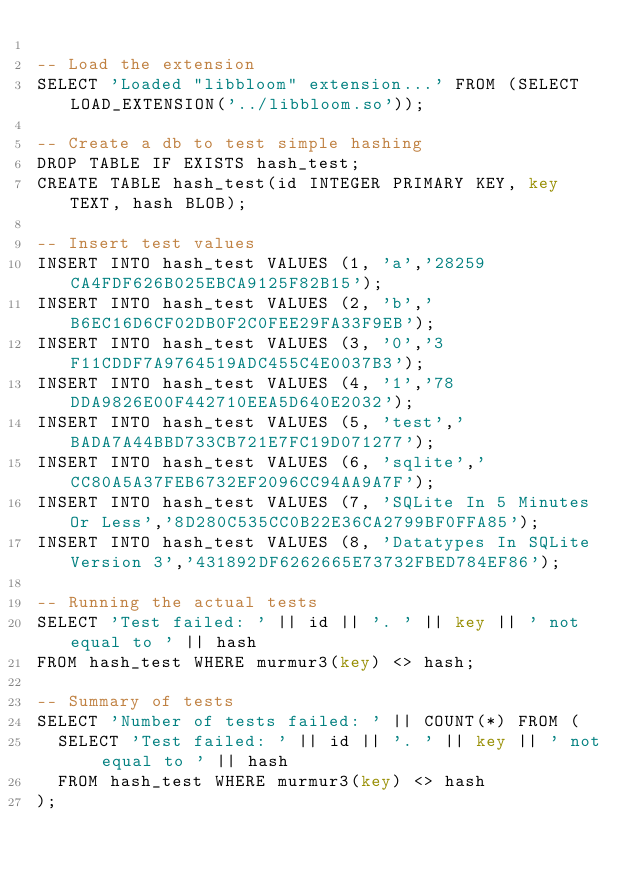<code> <loc_0><loc_0><loc_500><loc_500><_SQL_>
-- Load the extension
SELECT 'Loaded "libbloom" extension...' FROM (SELECT LOAD_EXTENSION('../libbloom.so'));

-- Create a db to test simple hashing
DROP TABLE IF EXISTS hash_test;
CREATE TABLE hash_test(id INTEGER PRIMARY KEY, key TEXT, hash BLOB);

-- Insert test values
INSERT INTO hash_test VALUES (1, 'a','28259CA4FDF626B025EBCA9125F82B15');
INSERT INTO hash_test VALUES (2, 'b','B6EC16D6CF02DB0F2C0FEE29FA33F9EB');
INSERT INTO hash_test VALUES (3, '0','3F11CDDF7A9764519ADC455C4E0037B3');
INSERT INTO hash_test VALUES (4, '1','78DDA9826E00F442710EEA5D640E2032');
INSERT INTO hash_test VALUES (5, 'test','BADA7A44BBD733CB721E7FC19D071277');
INSERT INTO hash_test VALUES (6, 'sqlite','CC80A5A37FEB6732EF2096CC94AA9A7F');
INSERT INTO hash_test VALUES (7, 'SQLite In 5 Minutes Or Less','8D280C535CC0B22E36CA2799BF0FFA85');
INSERT INTO hash_test VALUES (8, 'Datatypes In SQLite Version 3','431892DF6262665E73732FBED784EF86');

-- Running the actual tests
SELECT 'Test failed: ' || id || '. ' || key || ' not equal to ' || hash 
FROM hash_test WHERE murmur3(key) <> hash;

-- Summary of tests
SELECT 'Number of tests failed: ' || COUNT(*) FROM (
  SELECT 'Test failed: ' || id || '. ' || key || ' not equal to ' || hash 
  FROM hash_test WHERE murmur3(key) <> hash
);

</code> 